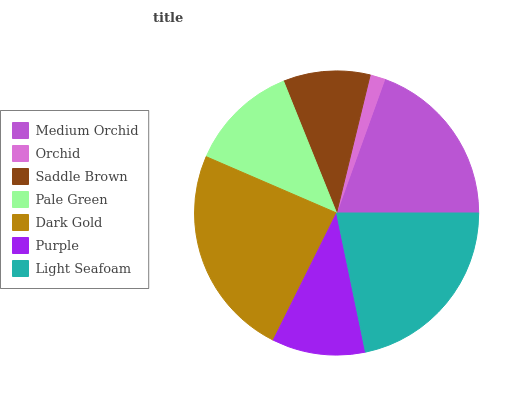Is Orchid the minimum?
Answer yes or no. Yes. Is Dark Gold the maximum?
Answer yes or no. Yes. Is Saddle Brown the minimum?
Answer yes or no. No. Is Saddle Brown the maximum?
Answer yes or no. No. Is Saddle Brown greater than Orchid?
Answer yes or no. Yes. Is Orchid less than Saddle Brown?
Answer yes or no. Yes. Is Orchid greater than Saddle Brown?
Answer yes or no. No. Is Saddle Brown less than Orchid?
Answer yes or no. No. Is Pale Green the high median?
Answer yes or no. Yes. Is Pale Green the low median?
Answer yes or no. Yes. Is Saddle Brown the high median?
Answer yes or no. No. Is Orchid the low median?
Answer yes or no. No. 